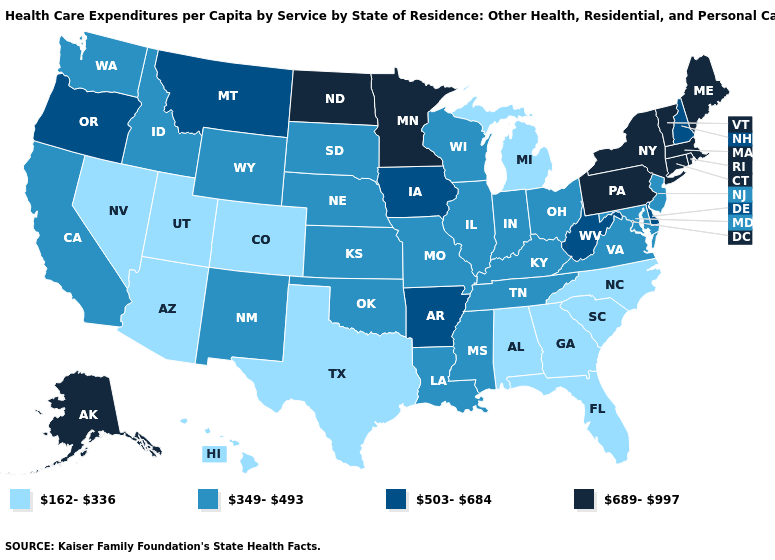What is the value of Kentucky?
Short answer required. 349-493. Name the states that have a value in the range 689-997?
Keep it brief. Alaska, Connecticut, Maine, Massachusetts, Minnesota, New York, North Dakota, Pennsylvania, Rhode Island, Vermont. Does Montana have the highest value in the USA?
Write a very short answer. No. Is the legend a continuous bar?
Write a very short answer. No. Among the states that border Alabama , which have the highest value?
Concise answer only. Mississippi, Tennessee. Name the states that have a value in the range 689-997?
Write a very short answer. Alaska, Connecticut, Maine, Massachusetts, Minnesota, New York, North Dakota, Pennsylvania, Rhode Island, Vermont. What is the value of New Jersey?
Short answer required. 349-493. Name the states that have a value in the range 162-336?
Keep it brief. Alabama, Arizona, Colorado, Florida, Georgia, Hawaii, Michigan, Nevada, North Carolina, South Carolina, Texas, Utah. What is the value of South Carolina?
Short answer required. 162-336. Name the states that have a value in the range 689-997?
Keep it brief. Alaska, Connecticut, Maine, Massachusetts, Minnesota, New York, North Dakota, Pennsylvania, Rhode Island, Vermont. Name the states that have a value in the range 503-684?
Short answer required. Arkansas, Delaware, Iowa, Montana, New Hampshire, Oregon, West Virginia. Among the states that border Utah , does Arizona have the lowest value?
Concise answer only. Yes. Name the states that have a value in the range 503-684?
Answer briefly. Arkansas, Delaware, Iowa, Montana, New Hampshire, Oregon, West Virginia. Name the states that have a value in the range 162-336?
Concise answer only. Alabama, Arizona, Colorado, Florida, Georgia, Hawaii, Michigan, Nevada, North Carolina, South Carolina, Texas, Utah. Which states have the lowest value in the Northeast?
Answer briefly. New Jersey. 